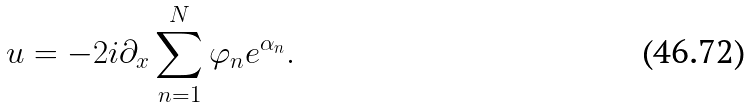Convert formula to latex. <formula><loc_0><loc_0><loc_500><loc_500>u = - 2 i \partial _ { x } \sum ^ { N } _ { n = 1 } \varphi _ { n } e ^ { \alpha _ { n } } .</formula> 